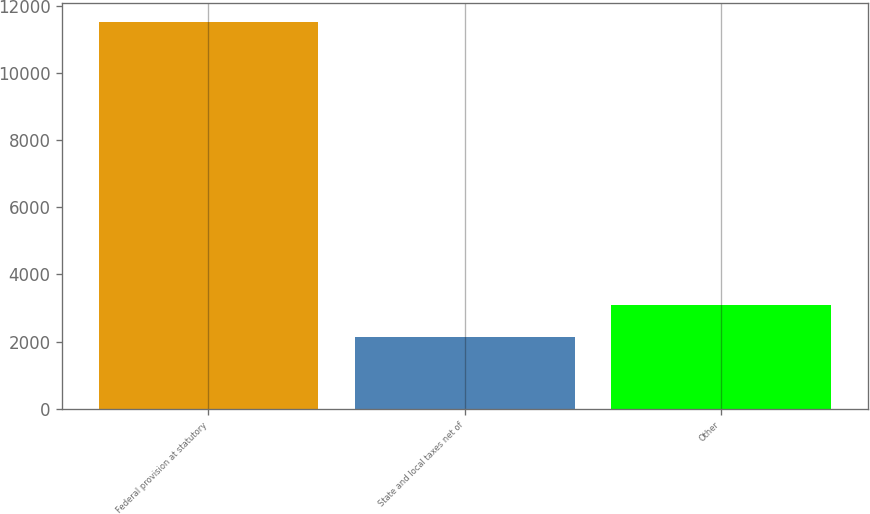Convert chart. <chart><loc_0><loc_0><loc_500><loc_500><bar_chart><fcel>Federal provision at statutory<fcel>State and local taxes net of<fcel>Other<nl><fcel>11522<fcel>2140<fcel>3078.2<nl></chart> 